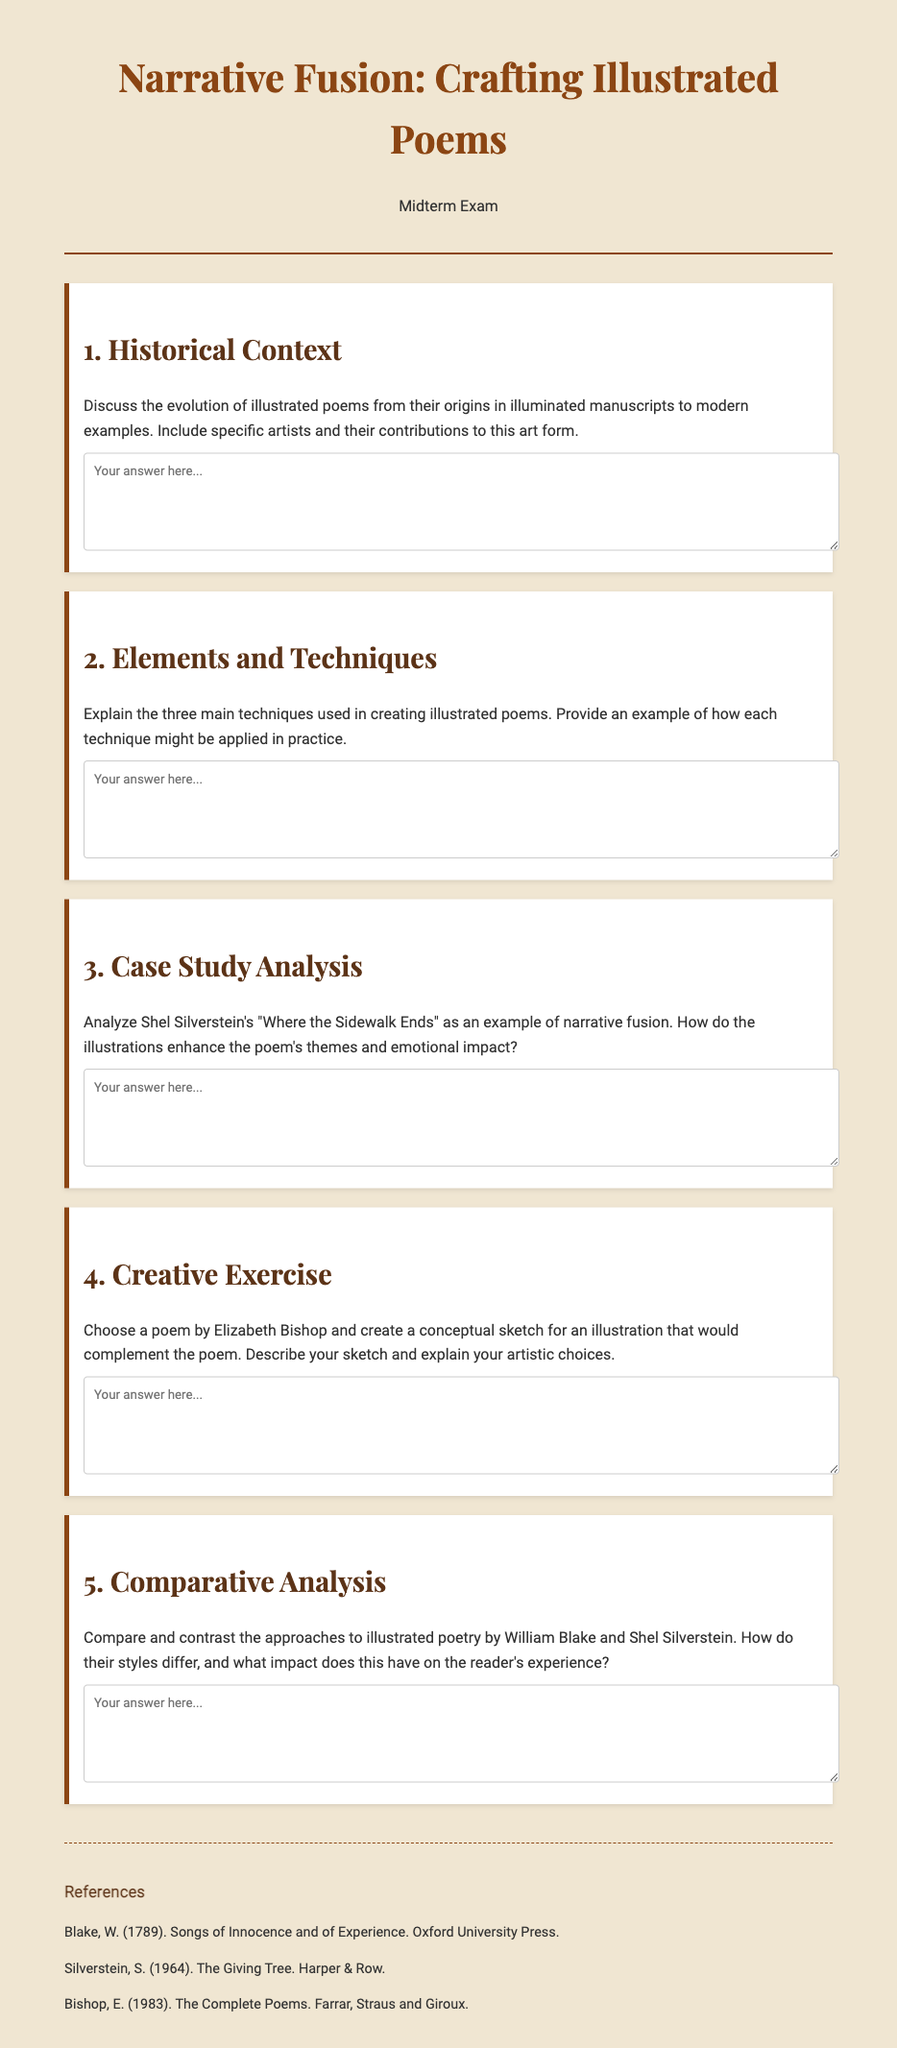What is the title of the exam? The exam is titled "Narrative Fusion: Crafting Illustrated Poems."
Answer: Narrative Fusion: Crafting Illustrated Poems Who is an example of an artist mentioned in the first question? The first question mentions artists who contributed to illustrated poems, but does not specify a name; however, historical context suggests artists like William Blake.
Answer: William Blake How many main techniques are discussed in the second question? The second question specifically refers to three main techniques used in creating illustrated poems.
Answer: Three Which poet is suggested for the creative exercise in question four? Question four explicitly asks for a poem by Elizabeth Bishop to be chosen for the creative exercise.
Answer: Elizabeth Bishop What year was "The Giving Tree" published? The reference section indicates that "The Giving Tree" was published in 1964.
Answer: 1964 What is the primary focus of the case study analysis in question three? The case study analysis in question three focuses on Shel Silverstein's "Where the Sidewalk Ends."
Answer: Where the Sidewalk Ends What type of exam is this document presenting? This document presents a midterm exam, as indicated in the header.
Answer: Midterm Exam Who authored the collection that includes "Songs of Innocence and of Experience"? The reference section shows that "Songs of Innocence and of Experience" was authored by William Blake.
Answer: William Blake 